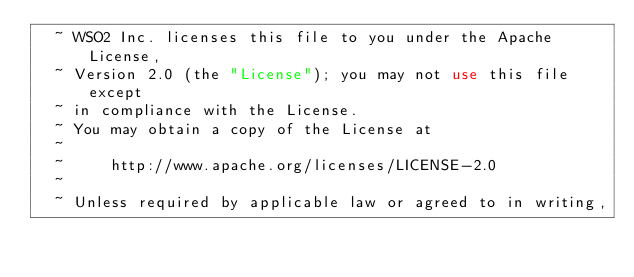<code> <loc_0><loc_0><loc_500><loc_500><_XML_>  ~ WSO2 Inc. licenses this file to you under the Apache License,
  ~ Version 2.0 (the "License"); you may not use this file except
  ~ in compliance with the License.
  ~ You may obtain a copy of the License at
  ~
  ~     http://www.apache.org/licenses/LICENSE-2.0
  ~
  ~ Unless required by applicable law or agreed to in writing,</code> 